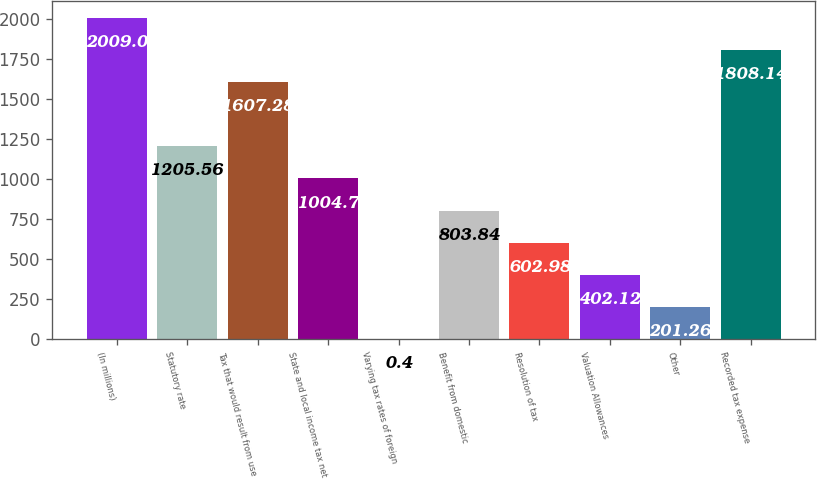<chart> <loc_0><loc_0><loc_500><loc_500><bar_chart><fcel>(In millions)<fcel>Statutory rate<fcel>Tax that would result from use<fcel>State and local income tax net<fcel>Varying tax rates of foreign<fcel>Benefit from domestic<fcel>Resolution of tax<fcel>Valuation Allowances<fcel>Other<fcel>Recorded tax expense<nl><fcel>2009<fcel>1205.56<fcel>1607.28<fcel>1004.7<fcel>0.4<fcel>803.84<fcel>602.98<fcel>402.12<fcel>201.26<fcel>1808.14<nl></chart> 